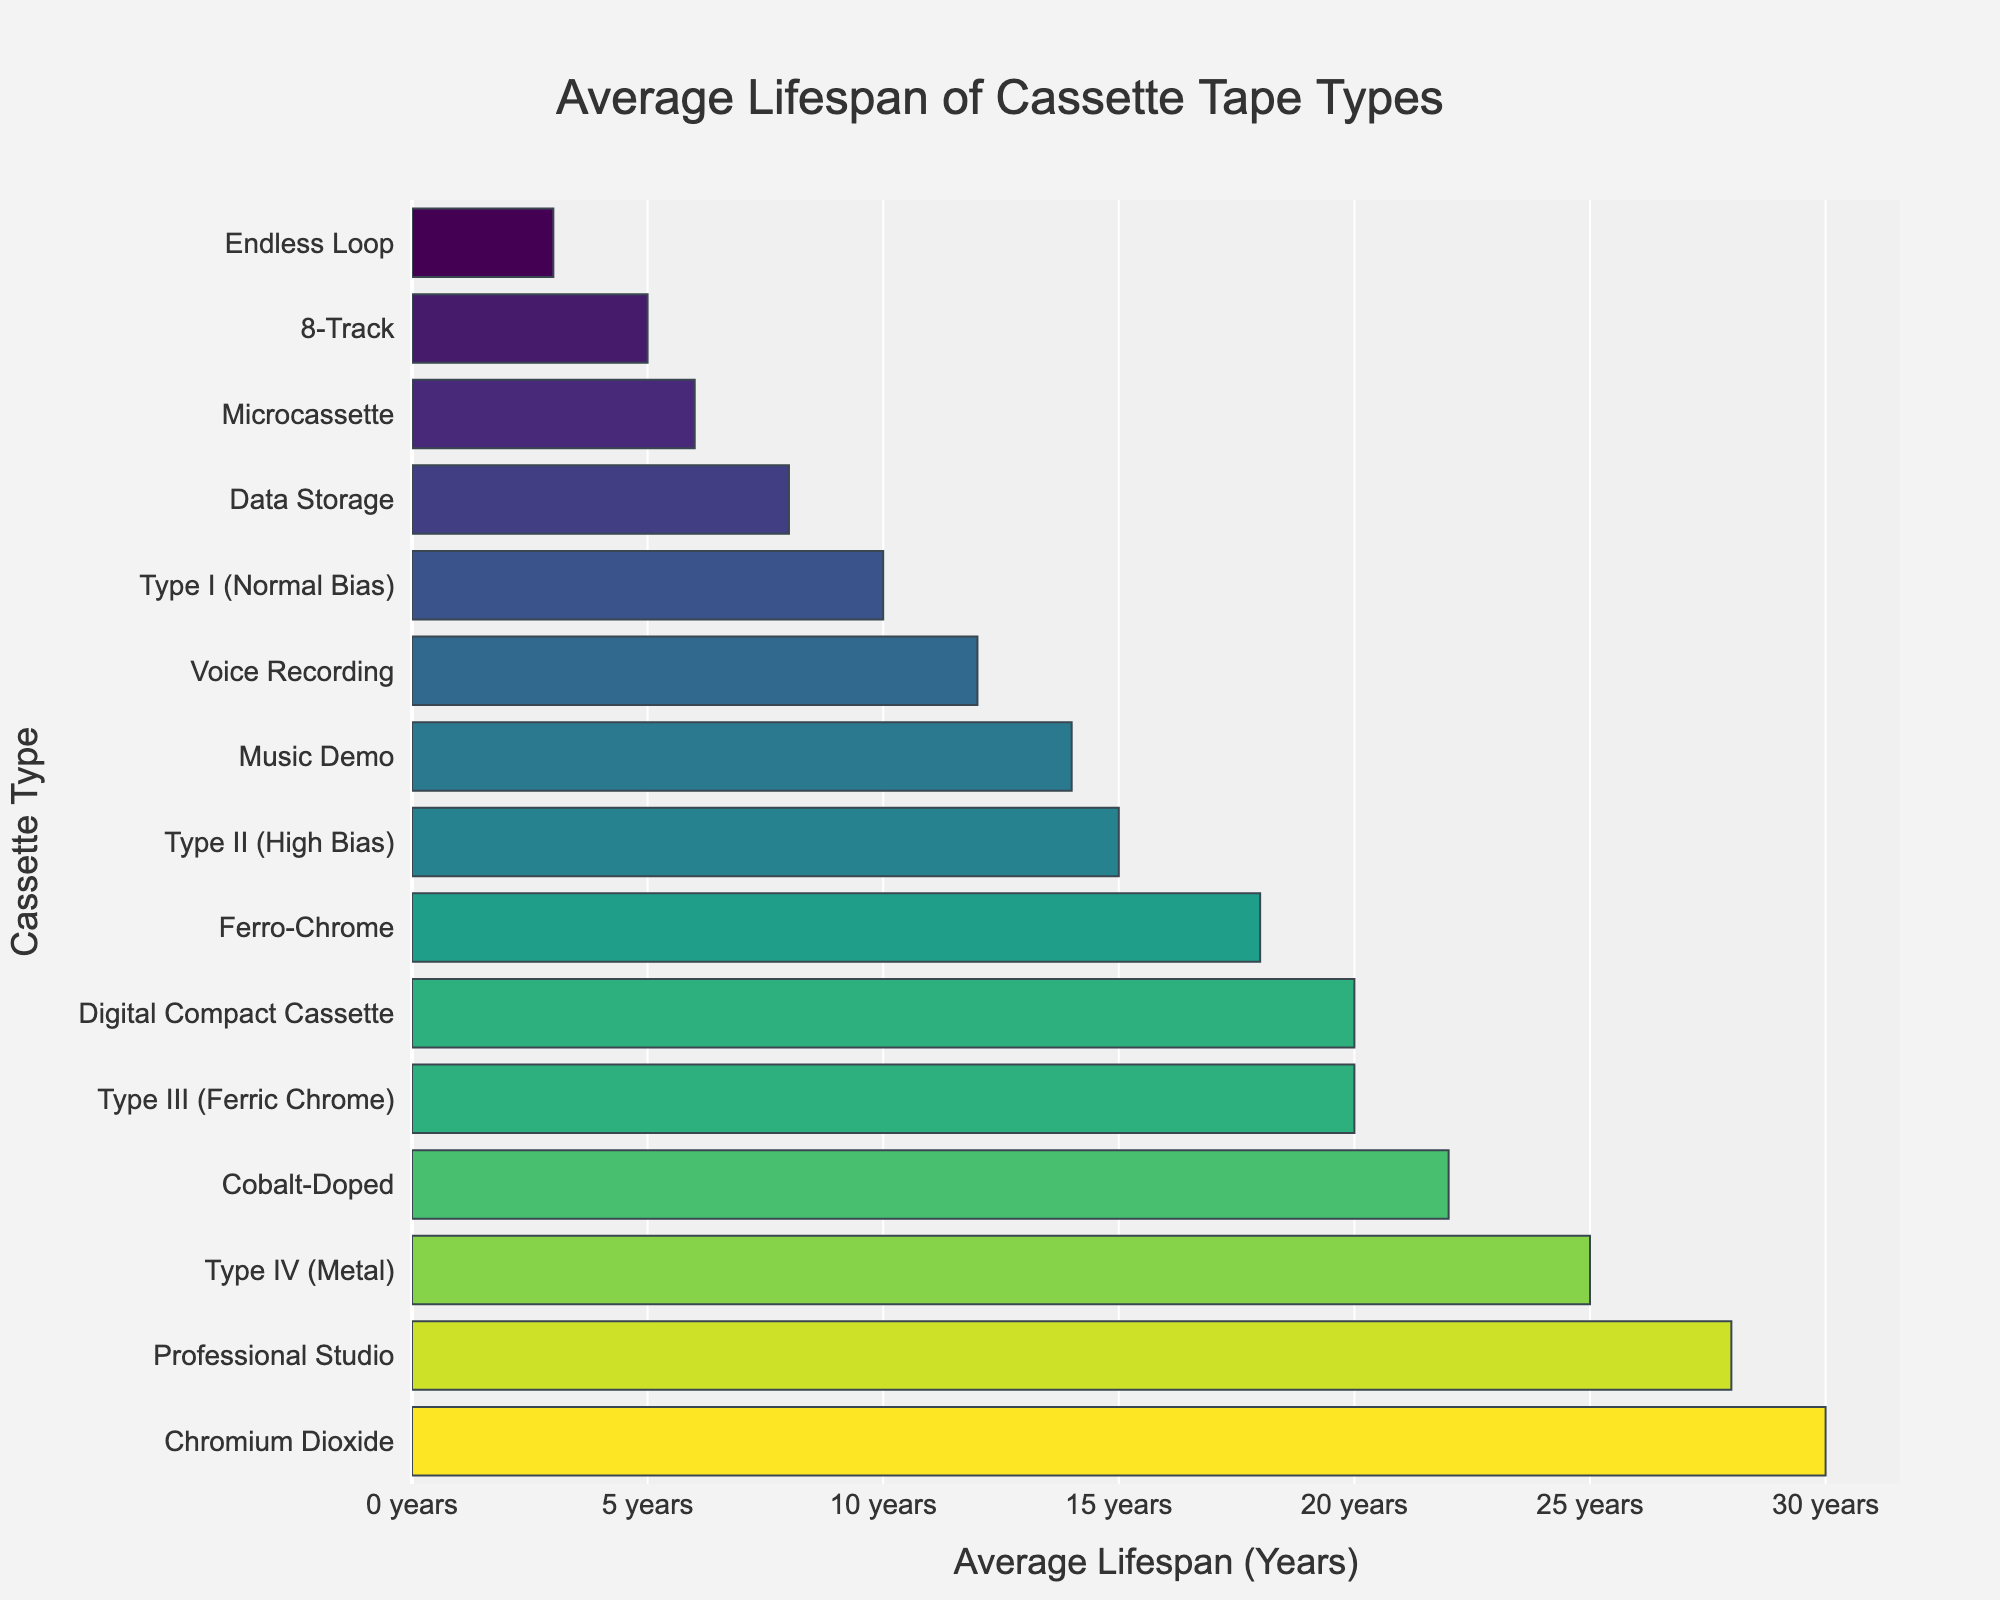Which cassette tape type has the longest average lifespan? Look at the bar that extends the furthest to the right, which indicates the longest lifespan.
Answer: Chromium Dioxide Which cassette tape type has the shortest average lifespan? Look at the bar that extends the least amount to the right, indicating the shortest lifespan.
Answer: Endless Loop How many cassette tape types have an average lifespan of 20 years or more? Count the bars that have lengths extending to 20 years or more on the horizontal axis.
Answer: 6 What is the difference in average lifespan between Type I (Normal Bias) and Type IV (Metal) cassettes? Subtract the lifespan of Type I (Normal Bias) from the lifespan of Type IV (Metal): 25 - 10.
Answer: 15 Which cassette tape type has a longer average lifespan: Ferro-Chrome or Cobalt-Doped? Compare the lengths of the bars for Ferro-Chrome and Cobalt-Doped.
Answer: Cobalt-Doped What is the combined average lifespan of Microcassette and 8-Track tapes? Add the lifespans of Microcassette and 8-Track: 6 + 5.
Answer: 11 What is the average lifespan of the three cassette types with the longest lifespans? Find the three bars with the longest lifespans, sum their values, and divide by 3: (Chromium Dioxide 30 + Professional Studio 28 + Cobalt-Doped 22)/3.
Answer: 26.67 Which has a higher average lifespan: Music Demo or Voice Recording? Compare the lengths of the bars for Music Demo and Voice Recording.
Answer: Music Demo How much longer is the average lifespan of Professional Studio compared to Data Storage tapes? Subtract the lifespan of Data Storage from Professional Studio: 28 - 8.
Answer: 20 Is the average lifespan of Digital Compact Cassette equal to the combined average lifespan of Voice Recording and 8-Track tapes? Calculate the combined lifespan of Voice Recording and 8-Track: 12 + 5 = 17. Compare it to the lifespan of Digital Compact Cassette: 20.
Answer: No 